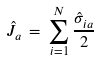<formula> <loc_0><loc_0><loc_500><loc_500>\hat { J } _ { a } \, = \, \sum _ { i = 1 } ^ { N } \frac { \hat { \sigma } _ { i a } } { 2 }</formula> 